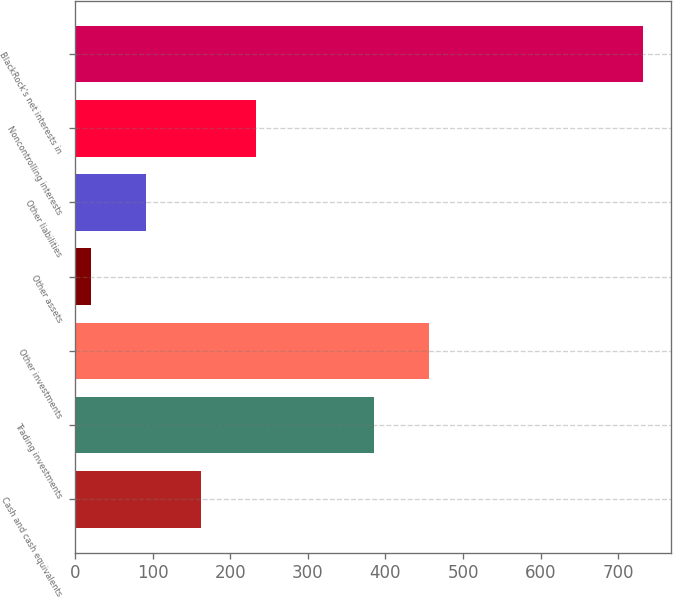<chart> <loc_0><loc_0><loc_500><loc_500><bar_chart><fcel>Cash and cash equivalents<fcel>Trading investments<fcel>Other investments<fcel>Other assets<fcel>Other liabilities<fcel>Noncontrolling interests<fcel>BlackRock's net interests in<nl><fcel>162.4<fcel>385<fcel>456.2<fcel>20<fcel>91.2<fcel>233.6<fcel>732<nl></chart> 